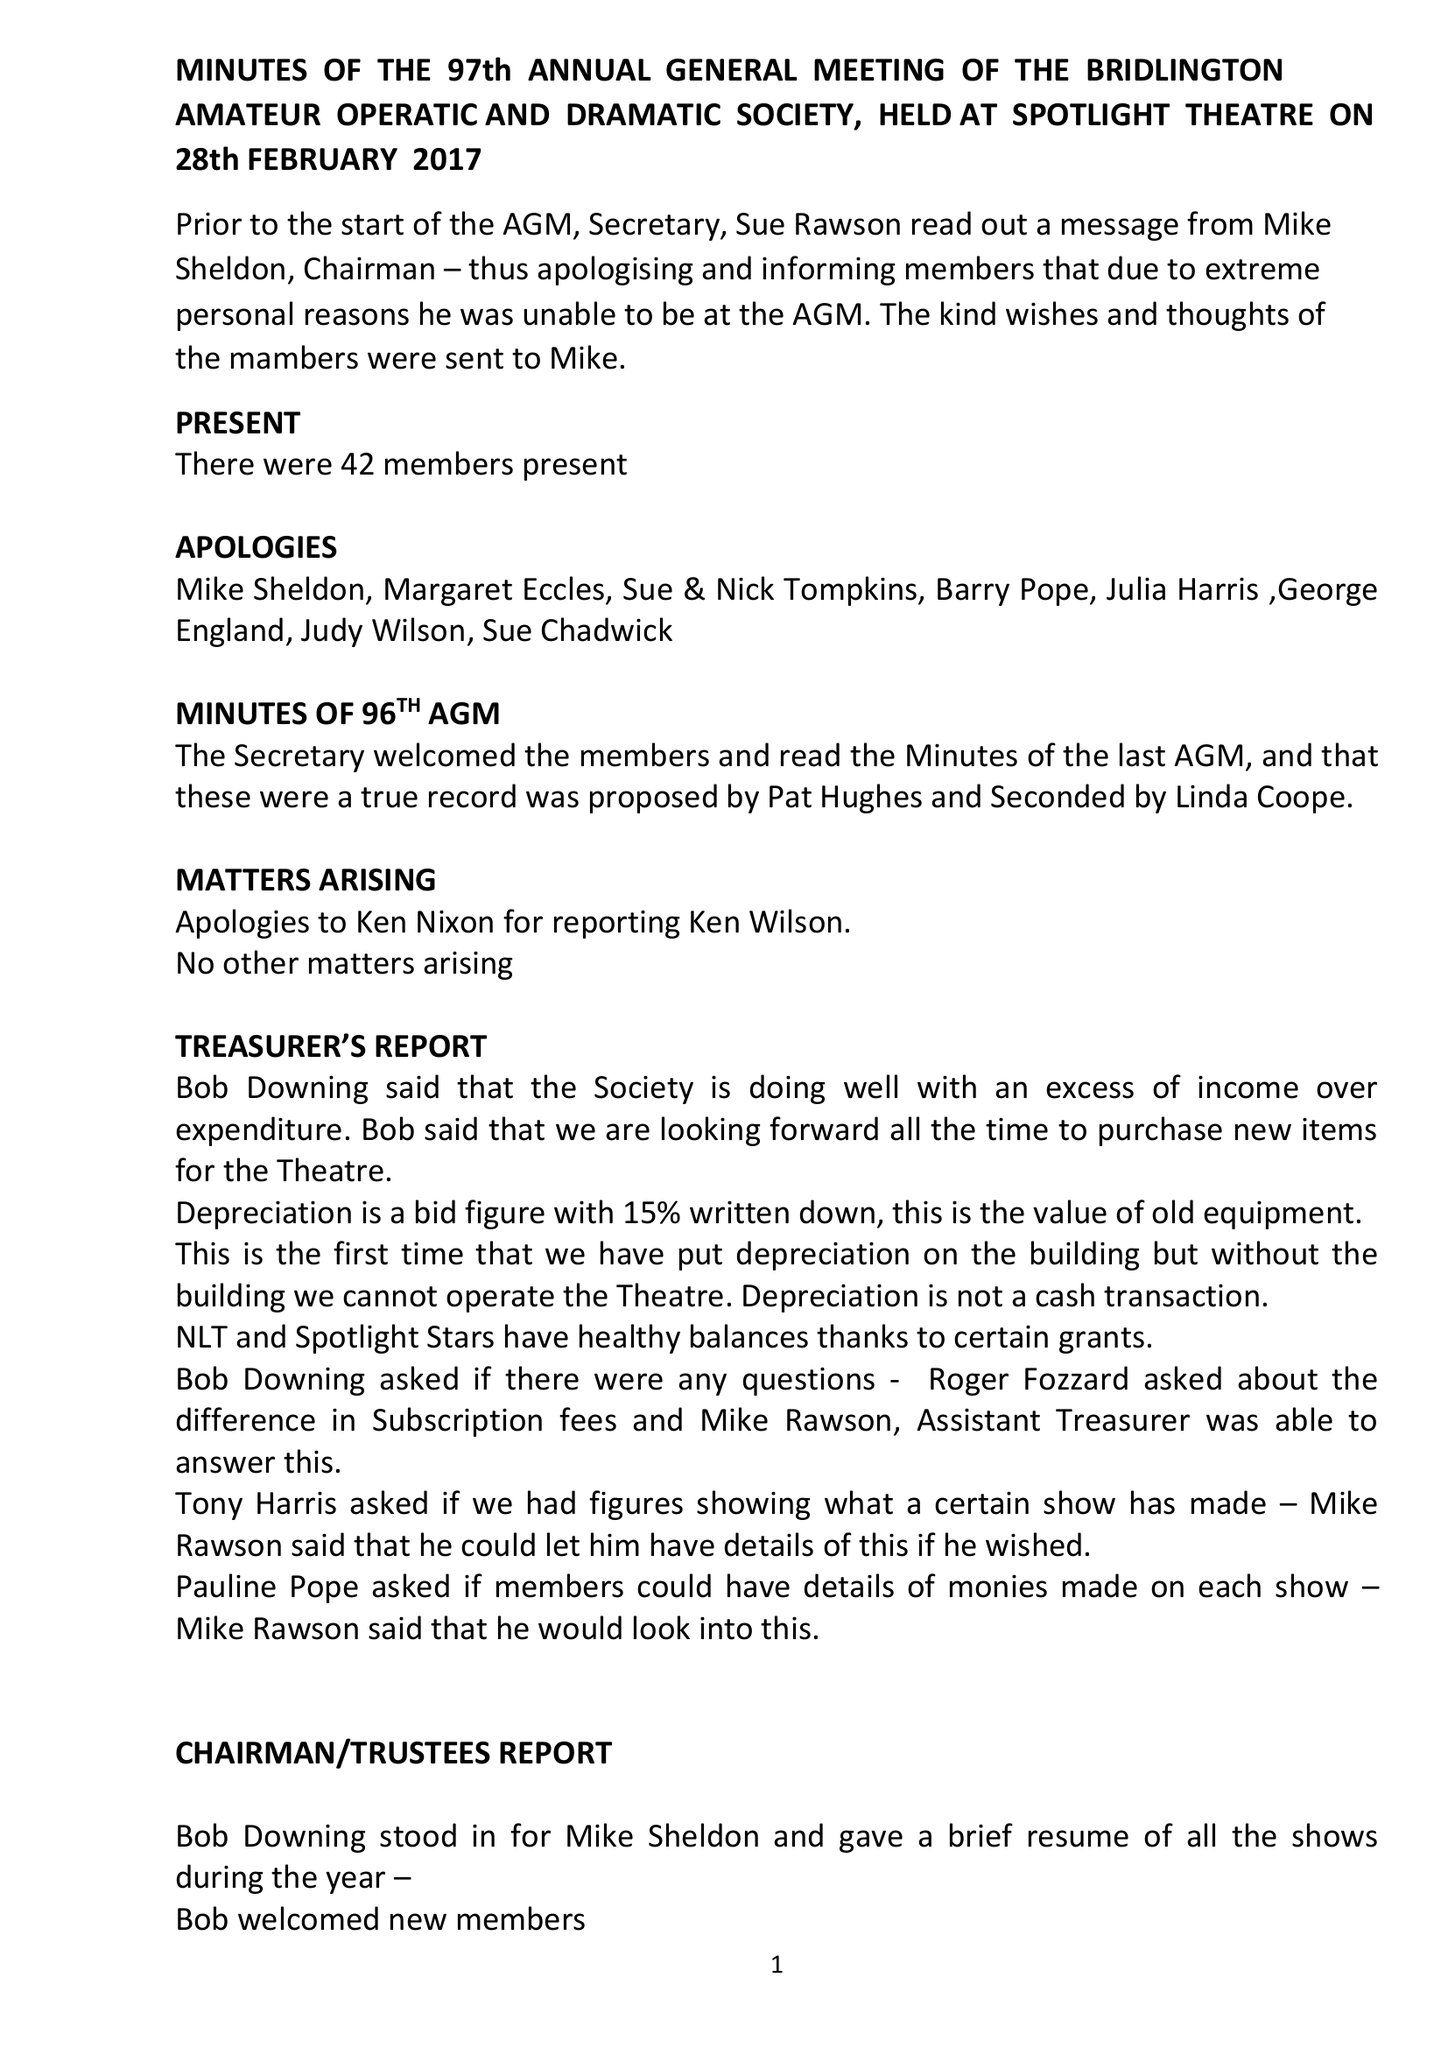What is the value for the charity_name?
Answer the question using a single word or phrase. Bridlington Amateur Operatic and Dramatic Society 